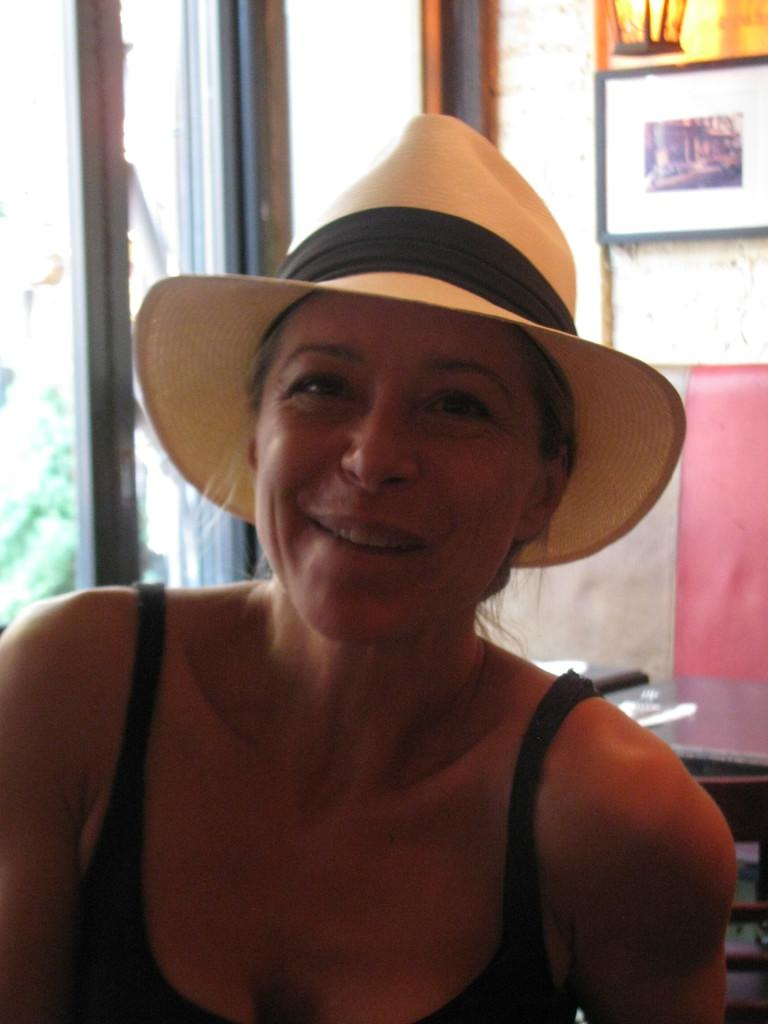Who is the main subject in the foreground of the image? There is a lady in the foreground of the image. What is the lady wearing on her head? The lady is wearing a hat. What can be seen in the background of the image? There is a table and photo frames on the wall in the background. What type of opening is visible in the background? The background appears to be a window. How many pigs are visible in the image? There are no pigs present in the image. What type of silverware is being used by the children in the image? There are no children or silverware present in the image. 